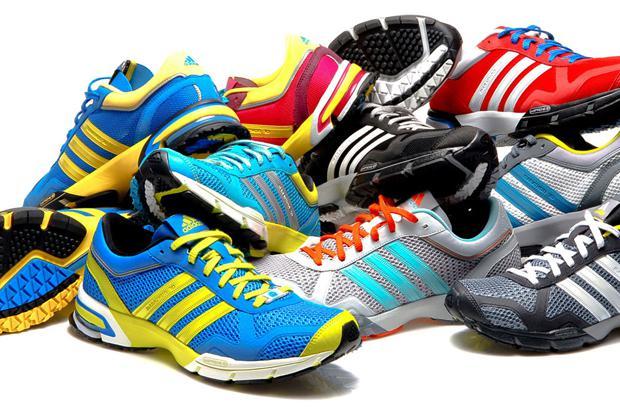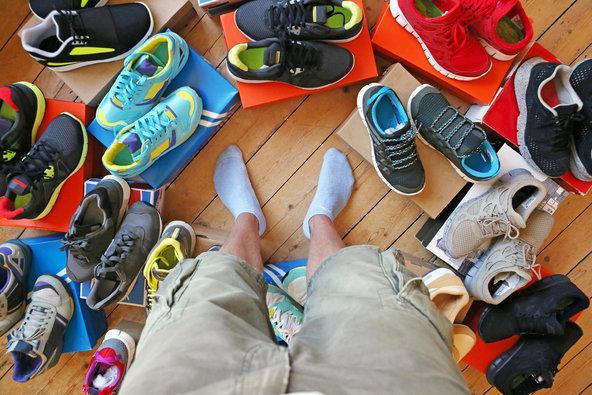The first image is the image on the left, the second image is the image on the right. Evaluate the accuracy of this statement regarding the images: "A human foot is present in an image with at least one sneaker also present.". Is it true? Answer yes or no. Yes. 